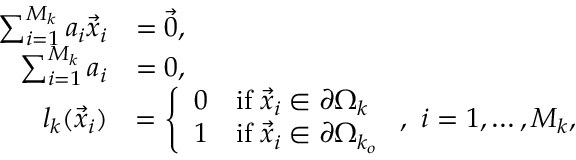Convert formula to latex. <formula><loc_0><loc_0><loc_500><loc_500>\begin{array} { r l } { \sum _ { i = 1 } ^ { M _ { k } } a _ { i } \vec { x } _ { i } } & { = \vec { 0 } , } \\ { \sum _ { i = 1 } ^ { M _ { k } } a _ { i } } & { = 0 , } \\ { l _ { k } ( \vec { x } _ { i } ) } & { = \left \{ \begin{array} { l l } { 0 } & { i f \, \vec { x } _ { i } \in \partial \Omega _ { k } } \\ { 1 } & { i f \, \vec { x } _ { i } \in \partial \Omega _ { k _ { o } } } \end{array} , \, i = 1 , \dots , M _ { k } , } \end{array}</formula> 